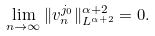<formula> <loc_0><loc_0><loc_500><loc_500>\lim _ { n \rightarrow \infty } \| v ^ { j _ { 0 } } _ { n } \| ^ { \alpha + 2 } _ { L ^ { \alpha + 2 } } = 0 .</formula> 